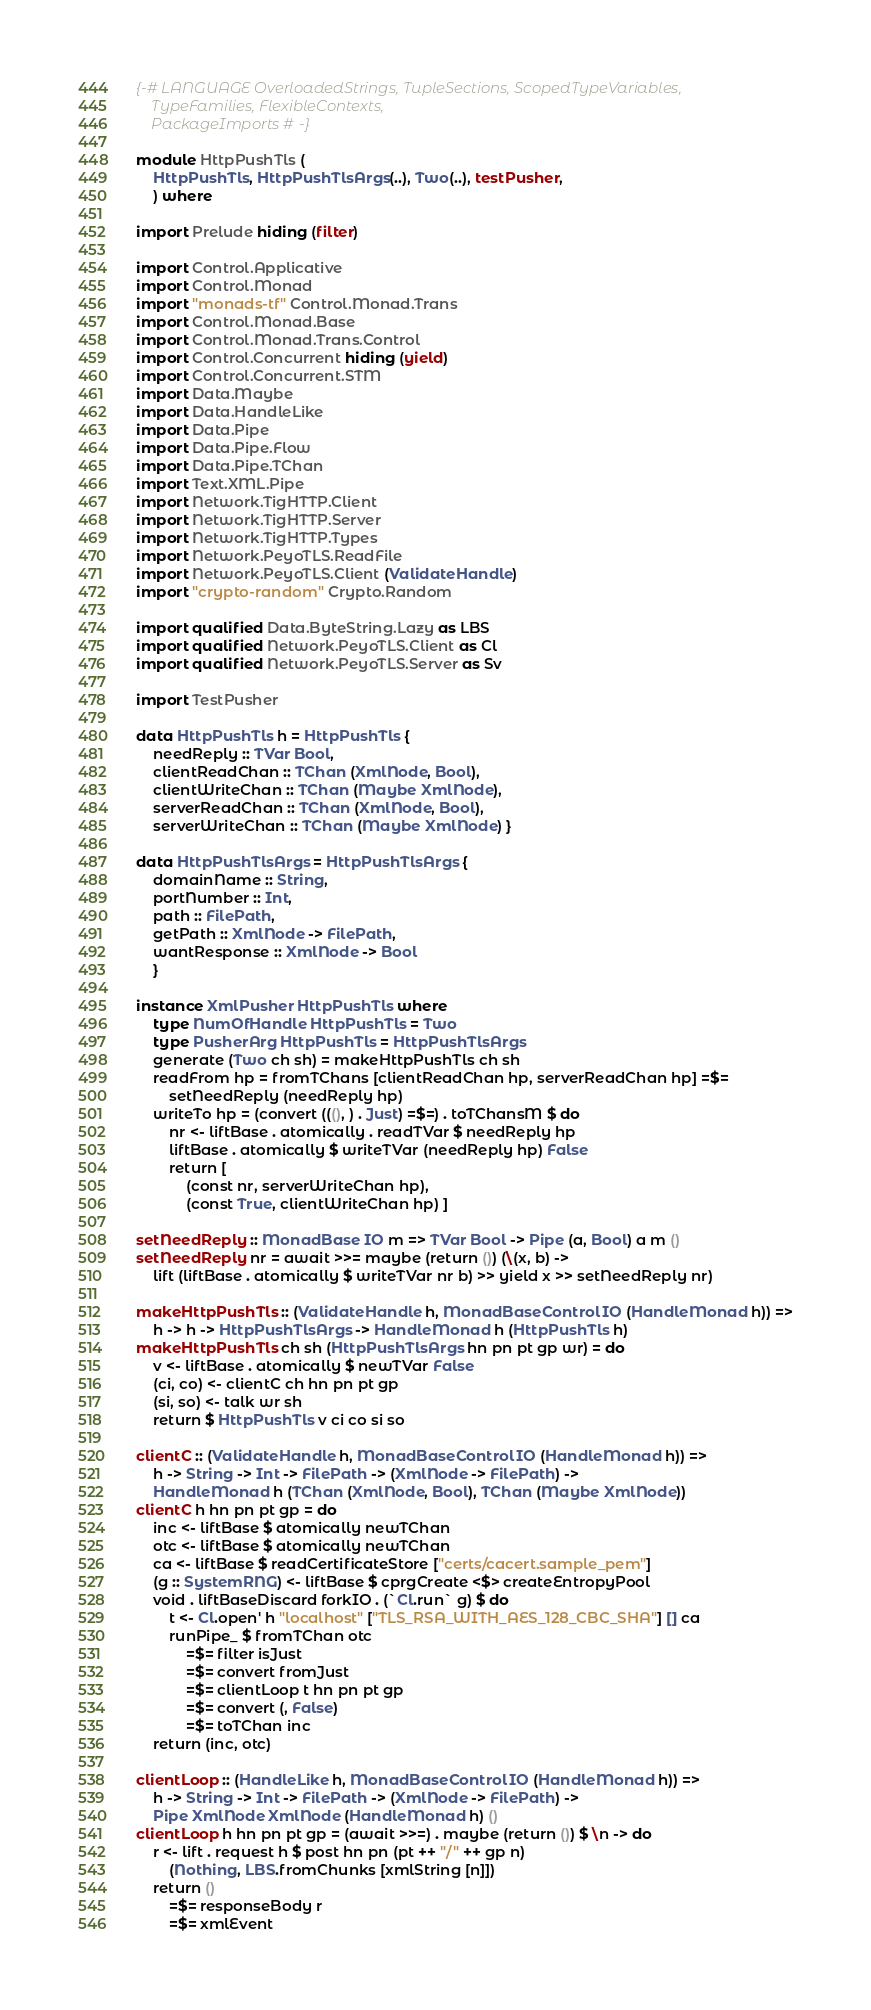Convert code to text. <code><loc_0><loc_0><loc_500><loc_500><_Haskell_>{-# LANGUAGE OverloadedStrings, TupleSections, ScopedTypeVariables,
	TypeFamilies, FlexibleContexts,
	PackageImports #-}

module HttpPushTls (
	HttpPushTls, HttpPushTlsArgs(..), Two(..), testPusher,
	) where

import Prelude hiding (filter)

import Control.Applicative
import Control.Monad
import "monads-tf" Control.Monad.Trans
import Control.Monad.Base
import Control.Monad.Trans.Control
import Control.Concurrent hiding (yield)
import Control.Concurrent.STM
import Data.Maybe
import Data.HandleLike
import Data.Pipe
import Data.Pipe.Flow
import Data.Pipe.TChan
import Text.XML.Pipe
import Network.TigHTTP.Client
import Network.TigHTTP.Server
import Network.TigHTTP.Types
import Network.PeyoTLS.ReadFile
import Network.PeyoTLS.Client (ValidateHandle)
import "crypto-random" Crypto.Random

import qualified Data.ByteString.Lazy as LBS
import qualified Network.PeyoTLS.Client as Cl
import qualified Network.PeyoTLS.Server as Sv

import TestPusher

data HttpPushTls h = HttpPushTls {
	needReply :: TVar Bool,
	clientReadChan :: TChan (XmlNode, Bool),
	clientWriteChan :: TChan (Maybe XmlNode),
	serverReadChan :: TChan (XmlNode, Bool),
	serverWriteChan :: TChan (Maybe XmlNode) }

data HttpPushTlsArgs = HttpPushTlsArgs {
	domainName :: String,
	portNumber :: Int,
	path :: FilePath,
	getPath :: XmlNode -> FilePath,
	wantResponse :: XmlNode -> Bool
	}

instance XmlPusher HttpPushTls where
	type NumOfHandle HttpPushTls = Two
	type PusherArg HttpPushTls = HttpPushTlsArgs
	generate (Two ch sh) = makeHttpPushTls ch sh
	readFrom hp = fromTChans [clientReadChan hp, serverReadChan hp] =$=
		setNeedReply (needReply hp)
	writeTo hp = (convert (((), ) . Just) =$=) . toTChansM $ do
		nr <- liftBase . atomically . readTVar $ needReply hp
		liftBase . atomically $ writeTVar (needReply hp) False
		return [
			(const nr, serverWriteChan hp),
			(const True, clientWriteChan hp) ]

setNeedReply :: MonadBase IO m => TVar Bool -> Pipe (a, Bool) a m ()
setNeedReply nr = await >>= maybe (return ()) (\(x, b) ->
	lift (liftBase . atomically $ writeTVar nr b) >> yield x >> setNeedReply nr)

makeHttpPushTls :: (ValidateHandle h, MonadBaseControl IO (HandleMonad h)) =>
	h -> h -> HttpPushTlsArgs -> HandleMonad h (HttpPushTls h)
makeHttpPushTls ch sh (HttpPushTlsArgs hn pn pt gp wr) = do
	v <- liftBase . atomically $ newTVar False
	(ci, co) <- clientC ch hn pn pt gp
	(si, so) <- talk wr sh
	return $ HttpPushTls v ci co si so

clientC :: (ValidateHandle h, MonadBaseControl IO (HandleMonad h)) =>
	h -> String -> Int -> FilePath -> (XmlNode -> FilePath) ->
	HandleMonad h (TChan (XmlNode, Bool), TChan (Maybe XmlNode))
clientC h hn pn pt gp = do
	inc <- liftBase $ atomically newTChan
	otc <- liftBase $ atomically newTChan
	ca <- liftBase $ readCertificateStore ["certs/cacert.sample_pem"]
	(g :: SystemRNG) <- liftBase $ cprgCreate <$> createEntropyPool
	void . liftBaseDiscard forkIO . (`Cl.run` g) $ do
		t <- Cl.open' h "localhost" ["TLS_RSA_WITH_AES_128_CBC_SHA"] [] ca
		runPipe_ $ fromTChan otc
			=$= filter isJust
			=$= convert fromJust
			=$= clientLoop t hn pn pt gp
			=$= convert (, False)
			=$= toTChan inc
	return (inc, otc)

clientLoop :: (HandleLike h, MonadBaseControl IO (HandleMonad h)) =>
	h -> String -> Int -> FilePath -> (XmlNode -> FilePath) ->
	Pipe XmlNode XmlNode (HandleMonad h) ()
clientLoop h hn pn pt gp = (await >>=) . maybe (return ()) $ \n -> do
	r <- lift . request h $ post hn pn (pt ++ "/" ++ gp n)
		(Nothing, LBS.fromChunks [xmlString [n]])
	return ()
		=$= responseBody r
		=$= xmlEvent</code> 